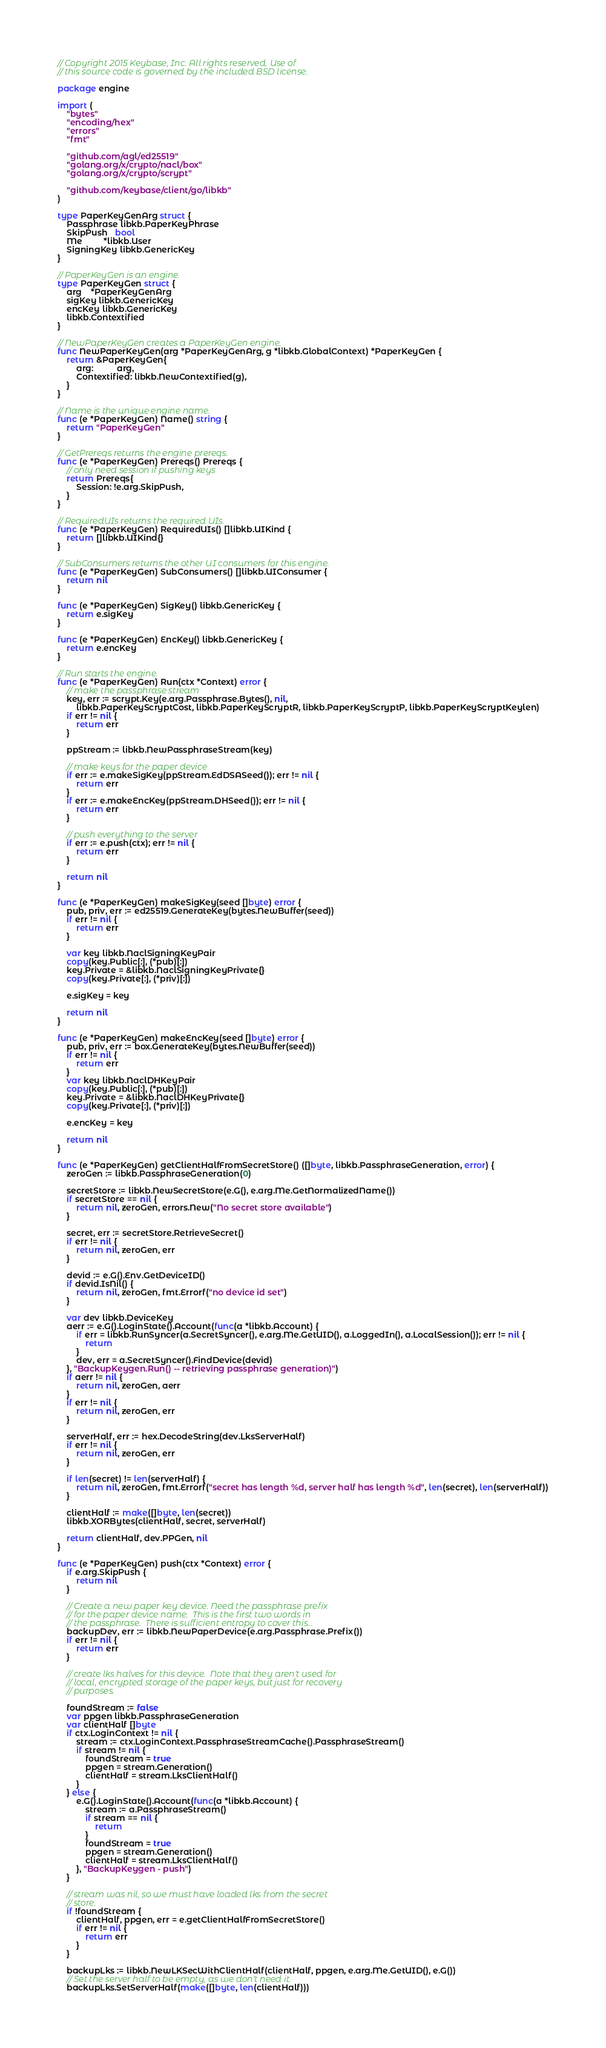<code> <loc_0><loc_0><loc_500><loc_500><_Go_>// Copyright 2015 Keybase, Inc. All rights reserved. Use of
// this source code is governed by the included BSD license.

package engine

import (
	"bytes"
	"encoding/hex"
	"errors"
	"fmt"

	"github.com/agl/ed25519"
	"golang.org/x/crypto/nacl/box"
	"golang.org/x/crypto/scrypt"

	"github.com/keybase/client/go/libkb"
)

type PaperKeyGenArg struct {
	Passphrase libkb.PaperKeyPhrase
	SkipPush   bool
	Me         *libkb.User
	SigningKey libkb.GenericKey
}

// PaperKeyGen is an engine.
type PaperKeyGen struct {
	arg    *PaperKeyGenArg
	sigKey libkb.GenericKey
	encKey libkb.GenericKey
	libkb.Contextified
}

// NewPaperKeyGen creates a PaperKeyGen engine.
func NewPaperKeyGen(arg *PaperKeyGenArg, g *libkb.GlobalContext) *PaperKeyGen {
	return &PaperKeyGen{
		arg:          arg,
		Contextified: libkb.NewContextified(g),
	}
}

// Name is the unique engine name.
func (e *PaperKeyGen) Name() string {
	return "PaperKeyGen"
}

// GetPrereqs returns the engine prereqs.
func (e *PaperKeyGen) Prereqs() Prereqs {
	// only need session if pushing keys
	return Prereqs{
		Session: !e.arg.SkipPush,
	}
}

// RequiredUIs returns the required UIs.
func (e *PaperKeyGen) RequiredUIs() []libkb.UIKind {
	return []libkb.UIKind{}
}

// SubConsumers returns the other UI consumers for this engine.
func (e *PaperKeyGen) SubConsumers() []libkb.UIConsumer {
	return nil
}

func (e *PaperKeyGen) SigKey() libkb.GenericKey {
	return e.sigKey
}

func (e *PaperKeyGen) EncKey() libkb.GenericKey {
	return e.encKey
}

// Run starts the engine.
func (e *PaperKeyGen) Run(ctx *Context) error {
	// make the passphrase stream
	key, err := scrypt.Key(e.arg.Passphrase.Bytes(), nil,
		libkb.PaperKeyScryptCost, libkb.PaperKeyScryptR, libkb.PaperKeyScryptP, libkb.PaperKeyScryptKeylen)
	if err != nil {
		return err
	}

	ppStream := libkb.NewPassphraseStream(key)

	// make keys for the paper device
	if err := e.makeSigKey(ppStream.EdDSASeed()); err != nil {
		return err
	}
	if err := e.makeEncKey(ppStream.DHSeed()); err != nil {
		return err
	}

	// push everything to the server
	if err := e.push(ctx); err != nil {
		return err
	}

	return nil
}

func (e *PaperKeyGen) makeSigKey(seed []byte) error {
	pub, priv, err := ed25519.GenerateKey(bytes.NewBuffer(seed))
	if err != nil {
		return err
	}

	var key libkb.NaclSigningKeyPair
	copy(key.Public[:], (*pub)[:])
	key.Private = &libkb.NaclSigningKeyPrivate{}
	copy(key.Private[:], (*priv)[:])

	e.sigKey = key

	return nil
}

func (e *PaperKeyGen) makeEncKey(seed []byte) error {
	pub, priv, err := box.GenerateKey(bytes.NewBuffer(seed))
	if err != nil {
		return err
	}
	var key libkb.NaclDHKeyPair
	copy(key.Public[:], (*pub)[:])
	key.Private = &libkb.NaclDHKeyPrivate{}
	copy(key.Private[:], (*priv)[:])

	e.encKey = key

	return nil
}

func (e *PaperKeyGen) getClientHalfFromSecretStore() ([]byte, libkb.PassphraseGeneration, error) {
	zeroGen := libkb.PassphraseGeneration(0)

	secretStore := libkb.NewSecretStore(e.G(), e.arg.Me.GetNormalizedName())
	if secretStore == nil {
		return nil, zeroGen, errors.New("No secret store available")
	}

	secret, err := secretStore.RetrieveSecret()
	if err != nil {
		return nil, zeroGen, err
	}

	devid := e.G().Env.GetDeviceID()
	if devid.IsNil() {
		return nil, zeroGen, fmt.Errorf("no device id set")
	}

	var dev libkb.DeviceKey
	aerr := e.G().LoginState().Account(func(a *libkb.Account) {
		if err = libkb.RunSyncer(a.SecretSyncer(), e.arg.Me.GetUID(), a.LoggedIn(), a.LocalSession()); err != nil {
			return
		}
		dev, err = a.SecretSyncer().FindDevice(devid)
	}, "BackupKeygen.Run() -- retrieving passphrase generation)")
	if aerr != nil {
		return nil, zeroGen, aerr
	}
	if err != nil {
		return nil, zeroGen, err
	}

	serverHalf, err := hex.DecodeString(dev.LksServerHalf)
	if err != nil {
		return nil, zeroGen, err
	}

	if len(secret) != len(serverHalf) {
		return nil, zeroGen, fmt.Errorf("secret has length %d, server half has length %d", len(secret), len(serverHalf))
	}

	clientHalf := make([]byte, len(secret))
	libkb.XORBytes(clientHalf, secret, serverHalf)

	return clientHalf, dev.PPGen, nil
}

func (e *PaperKeyGen) push(ctx *Context) error {
	if e.arg.SkipPush {
		return nil
	}

	// Create a new paper key device. Need the passphrase prefix
	// for the paper device name.  This is the first two words in
	// the passphrase.  There is sufficient entropy to cover this...
	backupDev, err := libkb.NewPaperDevice(e.arg.Passphrase.Prefix())
	if err != nil {
		return err
	}

	// create lks halves for this device.  Note that they aren't used for
	// local, encrypted storage of the paper keys, but just for recovery
	// purposes.

	foundStream := false
	var ppgen libkb.PassphraseGeneration
	var clientHalf []byte
	if ctx.LoginContext != nil {
		stream := ctx.LoginContext.PassphraseStreamCache().PassphraseStream()
		if stream != nil {
			foundStream = true
			ppgen = stream.Generation()
			clientHalf = stream.LksClientHalf()
		}
	} else {
		e.G().LoginState().Account(func(a *libkb.Account) {
			stream := a.PassphraseStream()
			if stream == nil {
				return
			}
			foundStream = true
			ppgen = stream.Generation()
			clientHalf = stream.LksClientHalf()
		}, "BackupKeygen - push")
	}

	// stream was nil, so we must have loaded lks from the secret
	// store.
	if !foundStream {
		clientHalf, ppgen, err = e.getClientHalfFromSecretStore()
		if err != nil {
			return err
		}
	}

	backupLks := libkb.NewLKSecWithClientHalf(clientHalf, ppgen, e.arg.Me.GetUID(), e.G())
	// Set the server half to be empty, as we don't need it.
	backupLks.SetServerHalf(make([]byte, len(clientHalf)))
</code> 